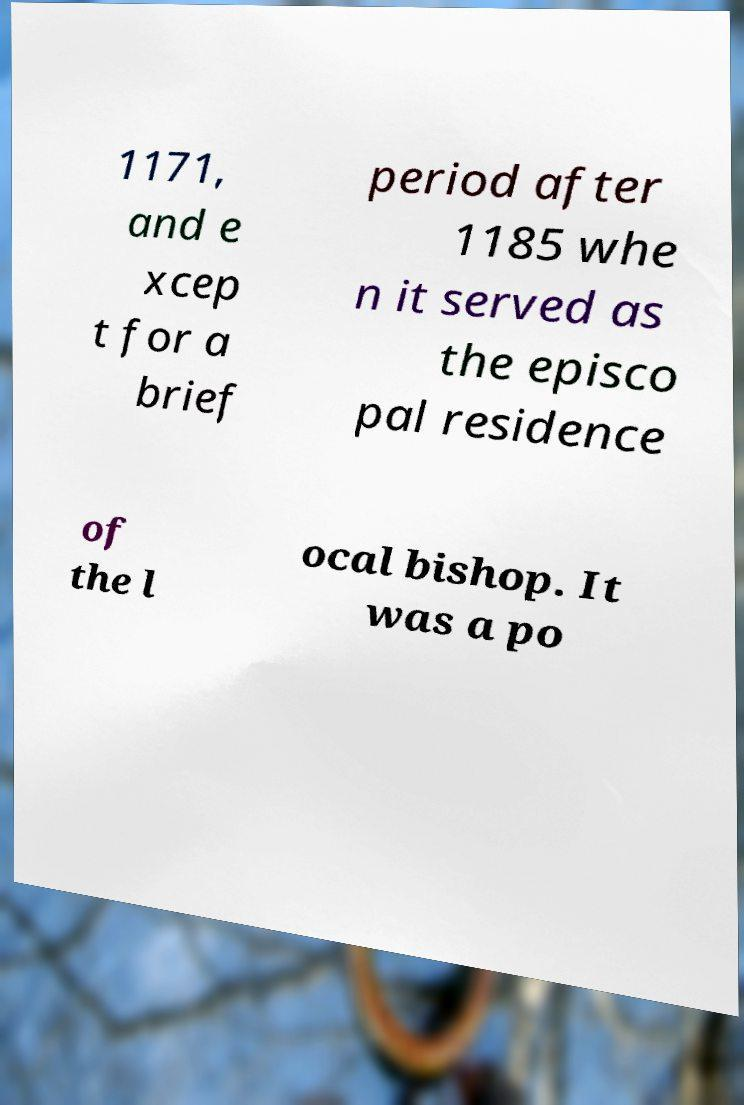Please identify and transcribe the text found in this image. 1171, and e xcep t for a brief period after 1185 whe n it served as the episco pal residence of the l ocal bishop. It was a po 